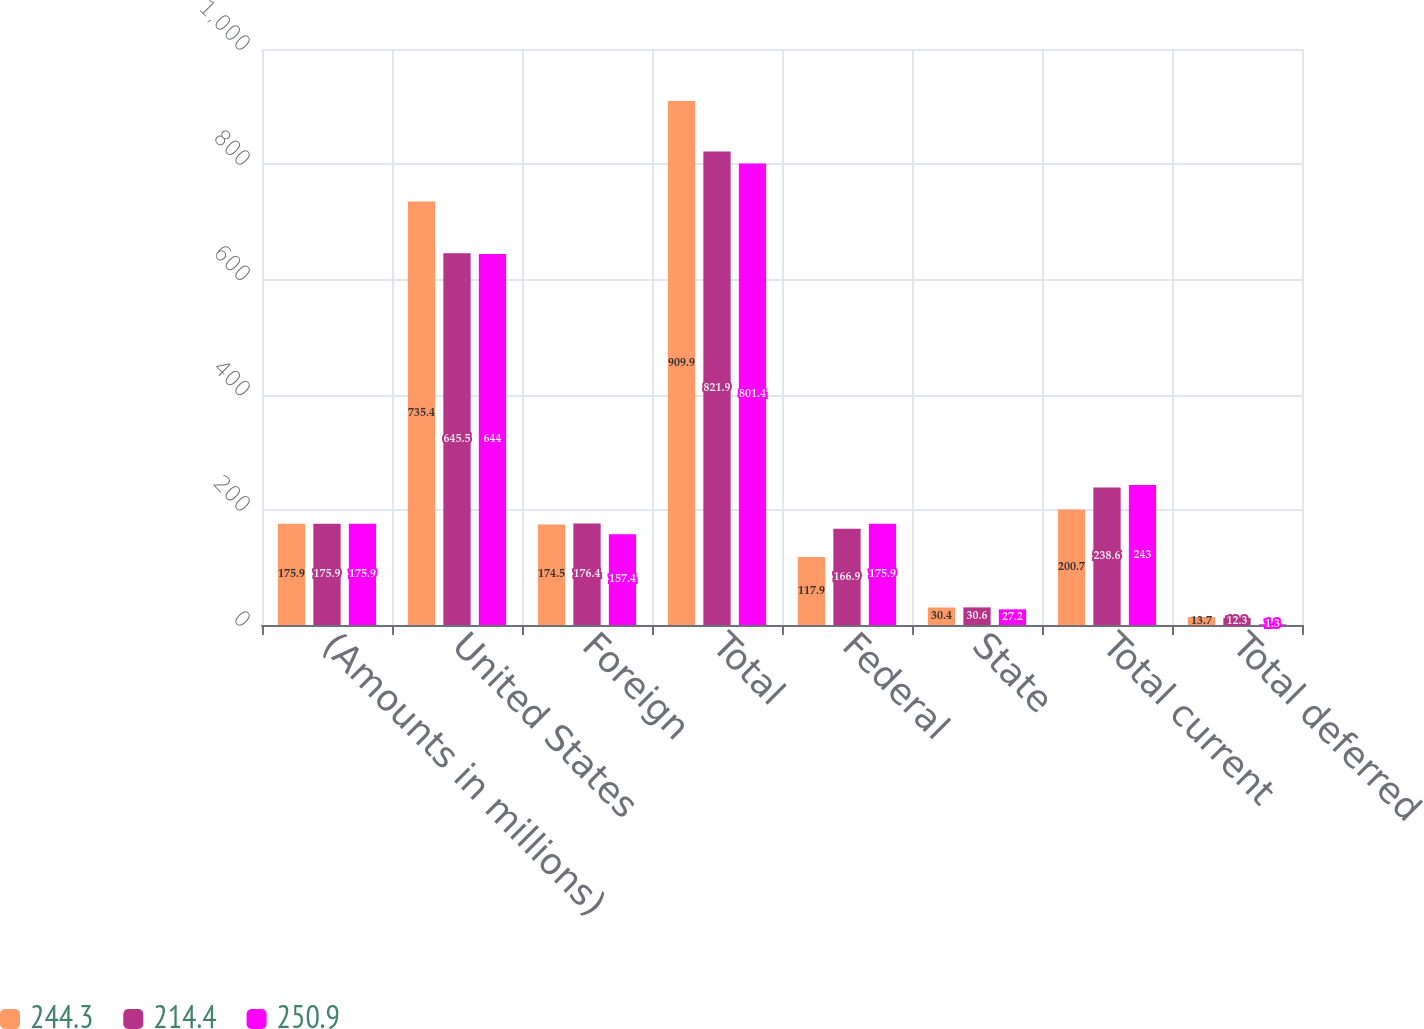<chart> <loc_0><loc_0><loc_500><loc_500><stacked_bar_chart><ecel><fcel>(Amounts in millions)<fcel>United States<fcel>Foreign<fcel>Total<fcel>Federal<fcel>State<fcel>Total current<fcel>Total deferred<nl><fcel>244.3<fcel>175.9<fcel>735.4<fcel>174.5<fcel>909.9<fcel>117.9<fcel>30.4<fcel>200.7<fcel>13.7<nl><fcel>214.4<fcel>175.9<fcel>645.5<fcel>176.4<fcel>821.9<fcel>166.9<fcel>30.6<fcel>238.6<fcel>12.3<nl><fcel>250.9<fcel>175.9<fcel>644<fcel>157.4<fcel>801.4<fcel>175.9<fcel>27.2<fcel>243<fcel>1.3<nl></chart> 